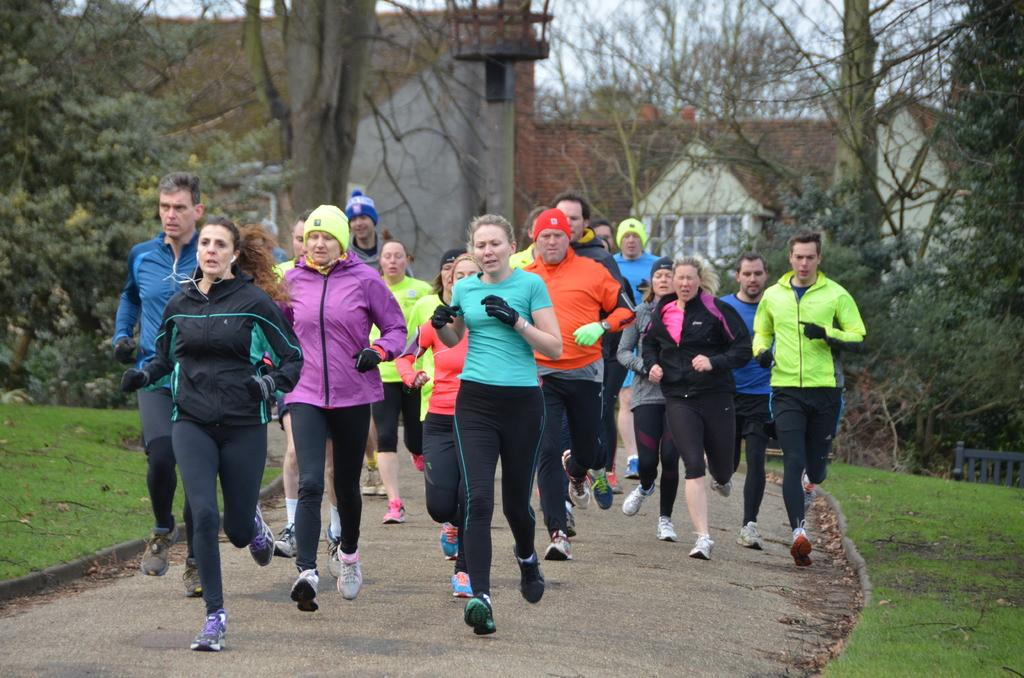What are the people in the image doing? The people in the image are running on a pathway. What type of surface are they running on? They are running on a pathway. What can be seen on both sides of the pathway? There is grass on both the left and right sides of the image. What is visible in the background of the image? There are trees and buildings in the background of the image. What type of cup is being used to measure the insect's profit in the image? There is no cup, insect, or profit present in the image. 